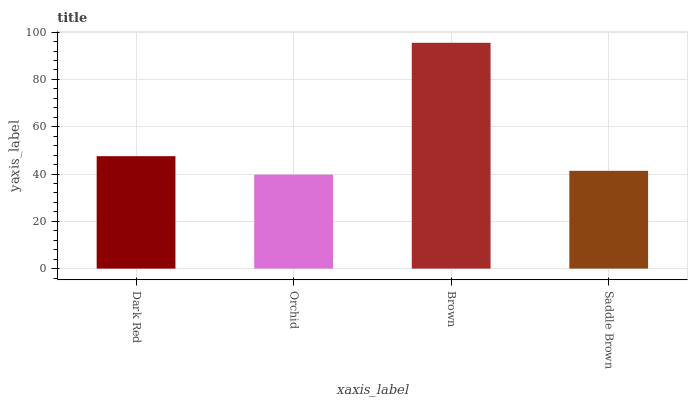Is Orchid the minimum?
Answer yes or no. Yes. Is Brown the maximum?
Answer yes or no. Yes. Is Brown the minimum?
Answer yes or no. No. Is Orchid the maximum?
Answer yes or no. No. Is Brown greater than Orchid?
Answer yes or no. Yes. Is Orchid less than Brown?
Answer yes or no. Yes. Is Orchid greater than Brown?
Answer yes or no. No. Is Brown less than Orchid?
Answer yes or no. No. Is Dark Red the high median?
Answer yes or no. Yes. Is Saddle Brown the low median?
Answer yes or no. Yes. Is Saddle Brown the high median?
Answer yes or no. No. Is Dark Red the low median?
Answer yes or no. No. 